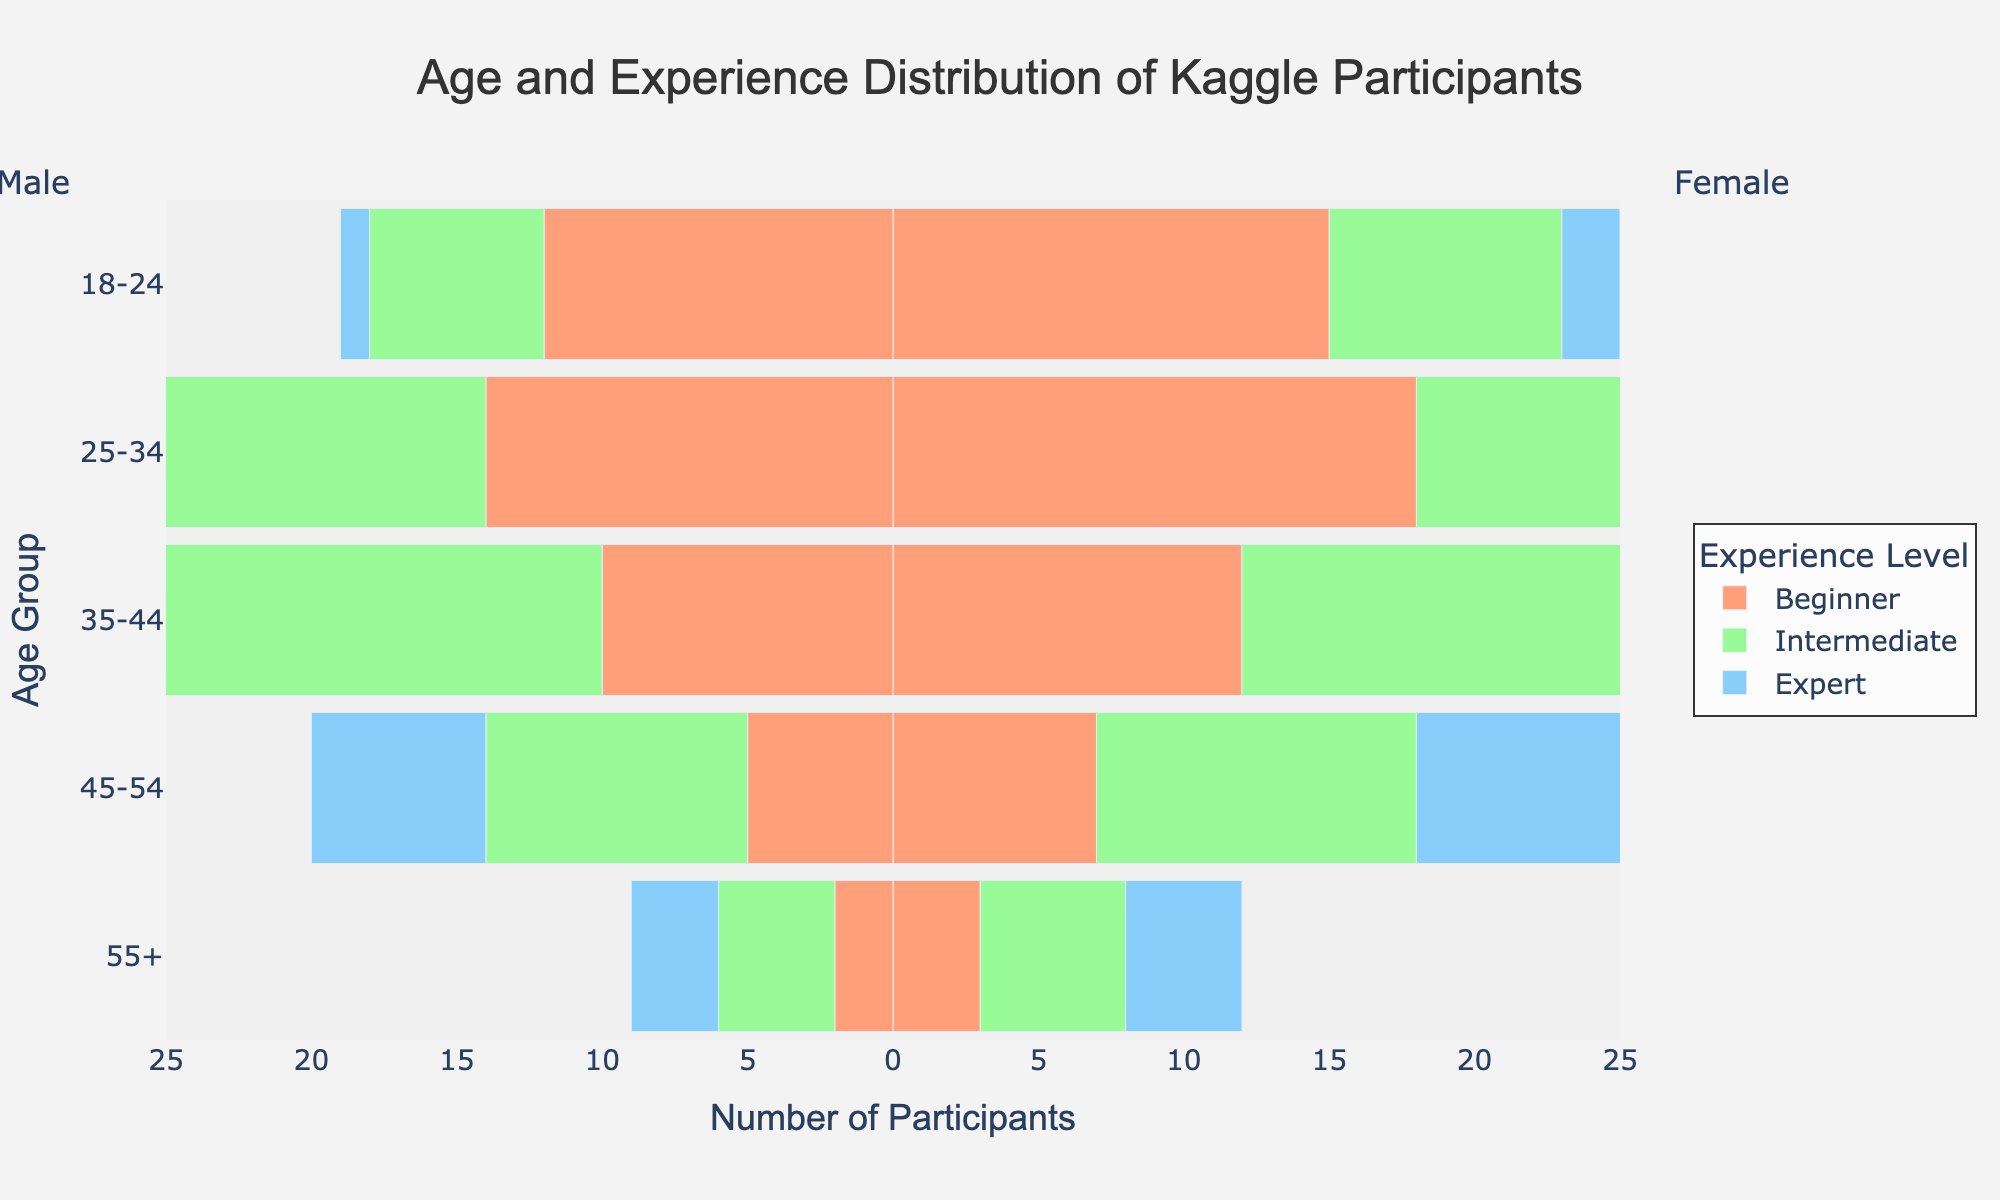What is the title of the figure? The title of the figure is located at the top center and provides an overview of what the figure represents. The title reads "Age and Experience Distribution of Kaggle Participants."
Answer: Age and Experience Distribution of Kaggle Participants Which experience level has the highest number of participants in the 25-34 age group? By analyzing the bars representing the 25-34 age group, both male and female, we observe that the Intermediate level has the highest number of participants compared to Beginner and Expert levels.
Answer: Intermediate For the 35-44 age group, how many more male Intermediate participants are there compared to male Beginners? The figure shows that in the 35-44 age group, there are 20 male Intermediate participants and 12 male Beginner participants. The difference is 20 - 12 = 8 participants.
Answer: 8 What is the total number of female participants in the 45-54 age group? Summing up the values for females in the 45-54 age group: Beginners (5), Intermediate (9), and Expert (6), we get 5 + 9 + 6 = 20 participants.
Answer: 20 How does the number of male Expert participants differ between the 25-34 and 35-44 age groups? The figure shows 9 male Expert participants in the 25-34 age group and 15 male Expert participants in the 35-44 age group. The difference is 15 - 9 = 6 participants.
Answer: 6 Which age group has the least number of female participants overall? By observing the lengths of the bars corresponding to female participants across all age groups, the 55+ age group has the least number of female participants: Beginners (2), Intermediate (4), and Expert (3).
Answer: 55+ In the 18-24 age group, how does the number of female Beginners compare to female Intermediate participants? The figure shows 12 female Beginners and 6 female Intermediate participants in the 18-24 age group. 12 is double the number of 6, indicating Beginners are twice as many.
Answer: Beginners are double What is the average number of male participants for the Intermediate experience level across all age groups? Summing the number of male Intermediate participants across age groups: 8 (18-24), 22 (25-34), 20 (35-44), and 11 (45-54), and 5 (55+), we get 8 + 22 + 20 + 11 + 5 = 66. Dividing by the number of age groups (5), 66 / 5 = 13.2.
Answer: 13.2 Which experience level has the most participants in the 55+ age group? By examining the bars for the 55+ age group, the Intermediate level has the most participants compared to Beginner and Expert levels for both males and females.
Answer: Intermediate 